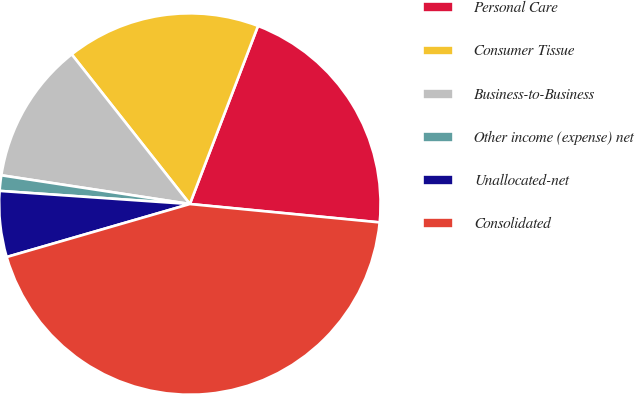Convert chart to OTSL. <chart><loc_0><loc_0><loc_500><loc_500><pie_chart><fcel>Personal Care<fcel>Consumer Tissue<fcel>Business-to-Business<fcel>Other income (expense) net<fcel>Unallocated-net<fcel>Consolidated<nl><fcel>20.72%<fcel>16.45%<fcel>11.96%<fcel>1.31%<fcel>5.58%<fcel>43.98%<nl></chart> 